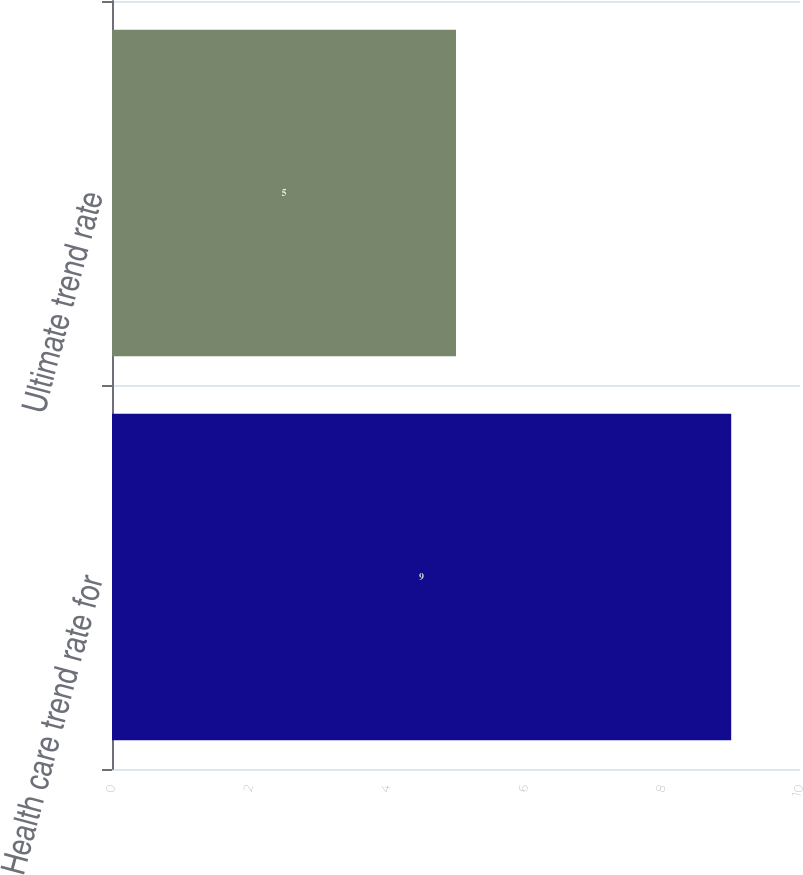<chart> <loc_0><loc_0><loc_500><loc_500><bar_chart><fcel>Health care trend rate for<fcel>Ultimate trend rate<nl><fcel>9<fcel>5<nl></chart> 